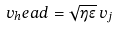<formula> <loc_0><loc_0><loc_500><loc_500>v _ { h } e a d = \sqrt { \eta \epsilon } \, v _ { j }</formula> 